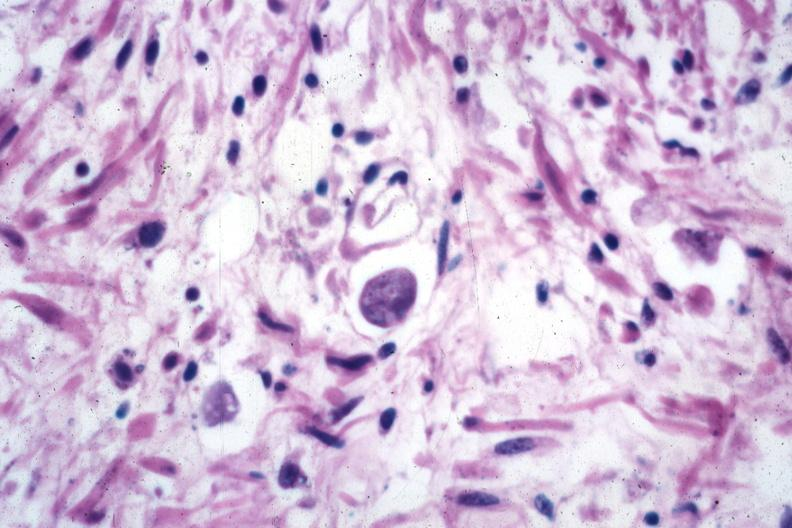s gastrointestinal present?
Answer the question using a single word or phrase. Yes 